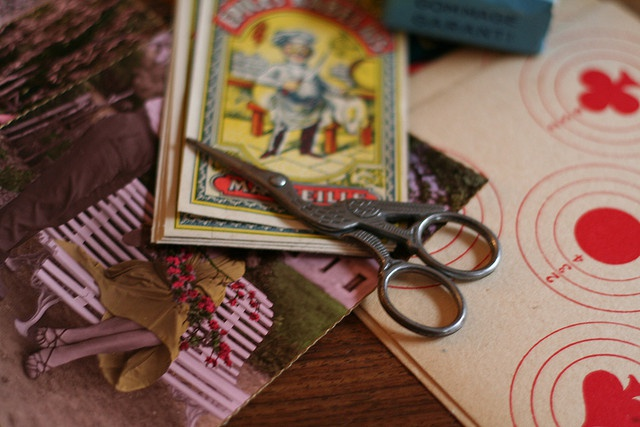Describe the objects in this image and their specific colors. I can see scissors in brown, black, maroon, and gray tones, people in brown, maroon, and black tones, bench in brown, lightpink, gray, maroon, and black tones, and people in brown, black, maroon, lightpink, and gray tones in this image. 